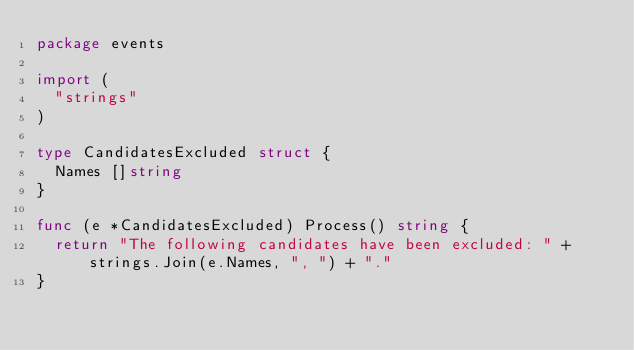<code> <loc_0><loc_0><loc_500><loc_500><_Go_>package events

import (
	"strings"
)

type CandidatesExcluded struct {
	Names []string
}

func (e *CandidatesExcluded) Process() string {
	return "The following candidates have been excluded: " + strings.Join(e.Names, ", ") + "."
}
</code> 